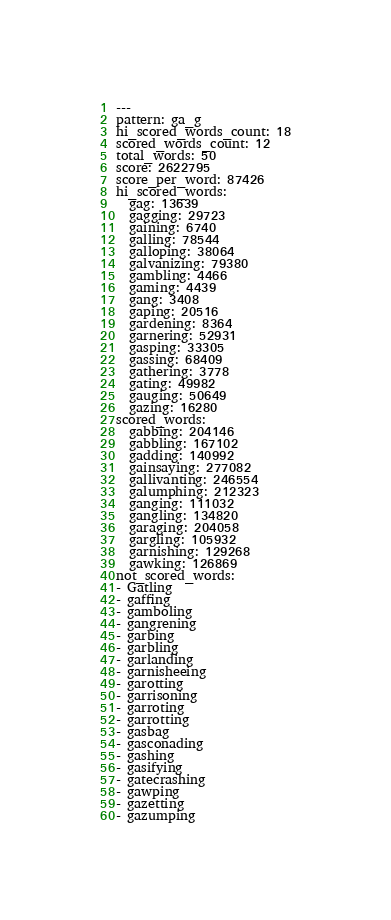<code> <loc_0><loc_0><loc_500><loc_500><_YAML_>---
pattern: ga_g
hi_scored_words_count: 18
scored_words_count: 12
total_words: 50
score: 2622795
score_per_word: 87426
hi_scored_words:
  gag: 13639
  gagging: 29723
  gaining: 6740
  galling: 78544
  galloping: 38064
  galvanizing: 79380
  gambling: 4466
  gaming: 4439
  gang: 3408
  gaping: 20516
  gardening: 8364
  garnering: 52931
  gasping: 33305
  gassing: 68409
  gathering: 3778
  gating: 49982
  gauging: 50649
  gazing: 16280
scored_words:
  gabbing: 204146
  gabbling: 167102
  gadding: 140992
  gainsaying: 277082
  gallivanting: 246554
  galumphing: 212323
  ganging: 111032
  gangling: 134820
  garaging: 204058
  gargling: 105932
  garnishing: 129268
  gawking: 126869
not_scored_words:
- Gatling
- gaffing
- gamboling
- gangrening
- garbing
- garbling
- garlanding
- garnisheeing
- garotting
- garrisoning
- garroting
- garrotting
- gasbag
- gasconading
- gashing
- gasifying
- gatecrashing
- gawping
- gazetting
- gazumping
</code> 